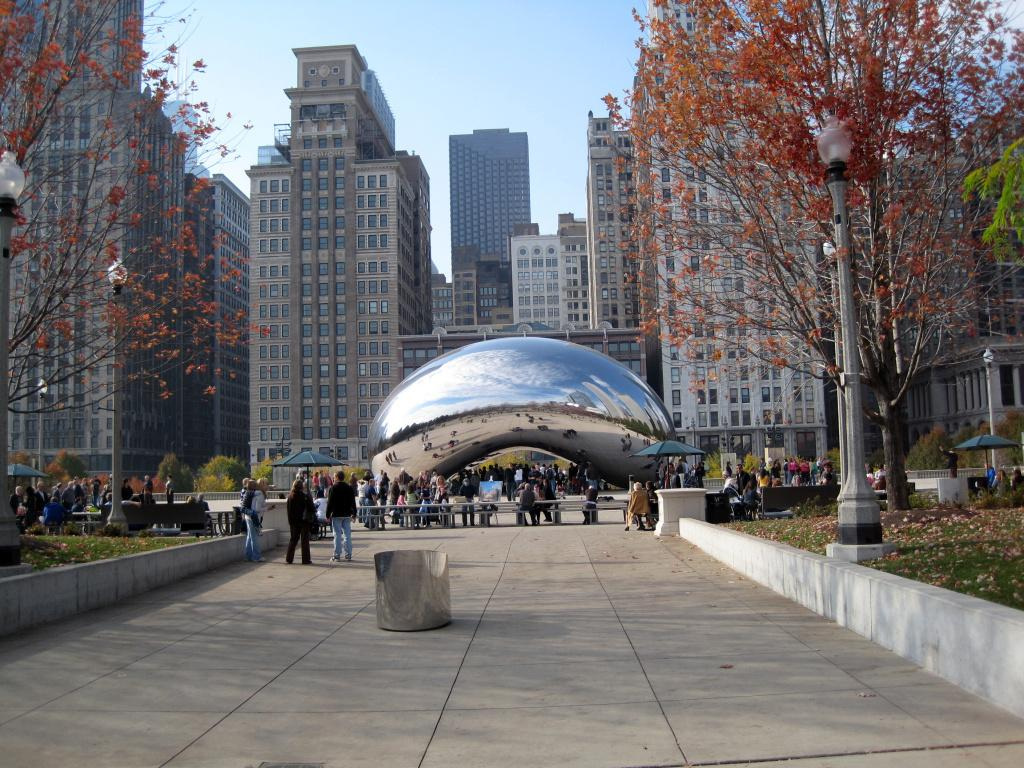What is happening in the image? There are people standing in the image. What is in front of the people? There is an object in front of the people. What can be seen in the background of the image? There are trees and buildings in the background of the image. What are the people writing on the gate in the image? There is no gate present in the image, and the people are not writing on anything. 